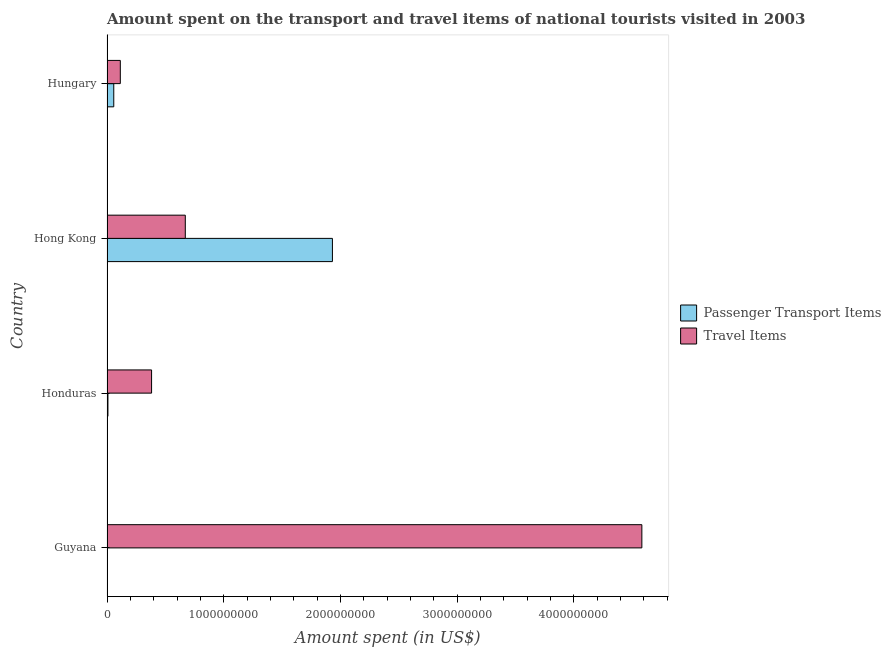How many groups of bars are there?
Ensure brevity in your answer.  4. Are the number of bars per tick equal to the number of legend labels?
Your answer should be compact. Yes. How many bars are there on the 2nd tick from the bottom?
Make the answer very short. 2. What is the label of the 3rd group of bars from the top?
Your answer should be very brief. Honduras. In how many cases, is the number of bars for a given country not equal to the number of legend labels?
Keep it short and to the point. 0. What is the amount spent on passenger transport items in Hungary?
Provide a short and direct response. 5.80e+07. Across all countries, what is the maximum amount spent in travel items?
Your answer should be compact. 4.58e+09. Across all countries, what is the minimum amount spent in travel items?
Your response must be concise. 1.14e+08. In which country was the amount spent on passenger transport items maximum?
Your answer should be compact. Hong Kong. In which country was the amount spent in travel items minimum?
Keep it short and to the point. Hungary. What is the total amount spent on passenger transport items in the graph?
Offer a terse response. 2.00e+09. What is the difference between the amount spent on passenger transport items in Guyana and that in Honduras?
Keep it short and to the point. -6.00e+06. What is the difference between the amount spent on passenger transport items in Guyana and the amount spent in travel items in Honduras?
Keep it short and to the point. -3.80e+08. What is the average amount spent in travel items per country?
Offer a terse response. 1.44e+09. What is the difference between the amount spent in travel items and amount spent on passenger transport items in Hong Kong?
Provide a succinct answer. -1.26e+09. In how many countries, is the amount spent in travel items greater than 1000000000 US$?
Your response must be concise. 1. What is the ratio of the amount spent on passenger transport items in Guyana to that in Hong Kong?
Keep it short and to the point. 0. What is the difference between the highest and the second highest amount spent in travel items?
Offer a terse response. 3.91e+09. What is the difference between the highest and the lowest amount spent in travel items?
Provide a succinct answer. 4.47e+09. In how many countries, is the amount spent on passenger transport items greater than the average amount spent on passenger transport items taken over all countries?
Offer a terse response. 1. What does the 2nd bar from the top in Guyana represents?
Provide a succinct answer. Passenger Transport Items. What does the 1st bar from the bottom in Guyana represents?
Offer a terse response. Passenger Transport Items. How many bars are there?
Provide a succinct answer. 8. Are the values on the major ticks of X-axis written in scientific E-notation?
Offer a very short reply. No. Does the graph contain grids?
Ensure brevity in your answer.  No. Where does the legend appear in the graph?
Offer a very short reply. Center right. How are the legend labels stacked?
Make the answer very short. Vertical. What is the title of the graph?
Provide a short and direct response. Amount spent on the transport and travel items of national tourists visited in 2003. What is the label or title of the X-axis?
Provide a succinct answer. Amount spent (in US$). What is the label or title of the Y-axis?
Keep it short and to the point. Country. What is the Amount spent (in US$) in Travel Items in Guyana?
Provide a succinct answer. 4.58e+09. What is the Amount spent (in US$) in Passenger Transport Items in Honduras?
Provide a succinct answer. 8.00e+06. What is the Amount spent (in US$) in Travel Items in Honduras?
Ensure brevity in your answer.  3.82e+08. What is the Amount spent (in US$) in Passenger Transport Items in Hong Kong?
Offer a terse response. 1.93e+09. What is the Amount spent (in US$) in Travel Items in Hong Kong?
Make the answer very short. 6.71e+08. What is the Amount spent (in US$) in Passenger Transport Items in Hungary?
Provide a short and direct response. 5.80e+07. What is the Amount spent (in US$) in Travel Items in Hungary?
Give a very brief answer. 1.14e+08. Across all countries, what is the maximum Amount spent (in US$) of Passenger Transport Items?
Ensure brevity in your answer.  1.93e+09. Across all countries, what is the maximum Amount spent (in US$) of Travel Items?
Keep it short and to the point. 4.58e+09. Across all countries, what is the minimum Amount spent (in US$) of Passenger Transport Items?
Offer a very short reply. 2.00e+06. Across all countries, what is the minimum Amount spent (in US$) in Travel Items?
Your response must be concise. 1.14e+08. What is the total Amount spent (in US$) of Travel Items in the graph?
Provide a succinct answer. 5.75e+09. What is the difference between the Amount spent (in US$) in Passenger Transport Items in Guyana and that in Honduras?
Provide a short and direct response. -6.00e+06. What is the difference between the Amount spent (in US$) of Travel Items in Guyana and that in Honduras?
Offer a terse response. 4.20e+09. What is the difference between the Amount spent (in US$) in Passenger Transport Items in Guyana and that in Hong Kong?
Keep it short and to the point. -1.93e+09. What is the difference between the Amount spent (in US$) of Travel Items in Guyana and that in Hong Kong?
Ensure brevity in your answer.  3.91e+09. What is the difference between the Amount spent (in US$) of Passenger Transport Items in Guyana and that in Hungary?
Offer a terse response. -5.60e+07. What is the difference between the Amount spent (in US$) in Travel Items in Guyana and that in Hungary?
Give a very brief answer. 4.47e+09. What is the difference between the Amount spent (in US$) of Passenger Transport Items in Honduras and that in Hong Kong?
Your response must be concise. -1.92e+09. What is the difference between the Amount spent (in US$) of Travel Items in Honduras and that in Hong Kong?
Provide a succinct answer. -2.89e+08. What is the difference between the Amount spent (in US$) in Passenger Transport Items in Honduras and that in Hungary?
Offer a terse response. -5.00e+07. What is the difference between the Amount spent (in US$) of Travel Items in Honduras and that in Hungary?
Your answer should be compact. 2.68e+08. What is the difference between the Amount spent (in US$) of Passenger Transport Items in Hong Kong and that in Hungary?
Your response must be concise. 1.87e+09. What is the difference between the Amount spent (in US$) in Travel Items in Hong Kong and that in Hungary?
Your answer should be very brief. 5.57e+08. What is the difference between the Amount spent (in US$) of Passenger Transport Items in Guyana and the Amount spent (in US$) of Travel Items in Honduras?
Your answer should be very brief. -3.80e+08. What is the difference between the Amount spent (in US$) in Passenger Transport Items in Guyana and the Amount spent (in US$) in Travel Items in Hong Kong?
Offer a very short reply. -6.69e+08. What is the difference between the Amount spent (in US$) of Passenger Transport Items in Guyana and the Amount spent (in US$) of Travel Items in Hungary?
Your answer should be compact. -1.12e+08. What is the difference between the Amount spent (in US$) in Passenger Transport Items in Honduras and the Amount spent (in US$) in Travel Items in Hong Kong?
Provide a succinct answer. -6.63e+08. What is the difference between the Amount spent (in US$) in Passenger Transport Items in Honduras and the Amount spent (in US$) in Travel Items in Hungary?
Keep it short and to the point. -1.06e+08. What is the difference between the Amount spent (in US$) of Passenger Transport Items in Hong Kong and the Amount spent (in US$) of Travel Items in Hungary?
Give a very brief answer. 1.82e+09. What is the average Amount spent (in US$) in Travel Items per country?
Your answer should be very brief. 1.44e+09. What is the difference between the Amount spent (in US$) of Passenger Transport Items and Amount spent (in US$) of Travel Items in Guyana?
Ensure brevity in your answer.  -4.58e+09. What is the difference between the Amount spent (in US$) in Passenger Transport Items and Amount spent (in US$) in Travel Items in Honduras?
Give a very brief answer. -3.74e+08. What is the difference between the Amount spent (in US$) in Passenger Transport Items and Amount spent (in US$) in Travel Items in Hong Kong?
Your response must be concise. 1.26e+09. What is the difference between the Amount spent (in US$) in Passenger Transport Items and Amount spent (in US$) in Travel Items in Hungary?
Your answer should be compact. -5.60e+07. What is the ratio of the Amount spent (in US$) in Travel Items in Guyana to that in Hong Kong?
Keep it short and to the point. 6.83. What is the ratio of the Amount spent (in US$) in Passenger Transport Items in Guyana to that in Hungary?
Give a very brief answer. 0.03. What is the ratio of the Amount spent (in US$) of Travel Items in Guyana to that in Hungary?
Give a very brief answer. 40.21. What is the ratio of the Amount spent (in US$) of Passenger Transport Items in Honduras to that in Hong Kong?
Your response must be concise. 0. What is the ratio of the Amount spent (in US$) in Travel Items in Honduras to that in Hong Kong?
Your response must be concise. 0.57. What is the ratio of the Amount spent (in US$) of Passenger Transport Items in Honduras to that in Hungary?
Make the answer very short. 0.14. What is the ratio of the Amount spent (in US$) in Travel Items in Honduras to that in Hungary?
Your response must be concise. 3.35. What is the ratio of the Amount spent (in US$) of Passenger Transport Items in Hong Kong to that in Hungary?
Provide a short and direct response. 33.31. What is the ratio of the Amount spent (in US$) in Travel Items in Hong Kong to that in Hungary?
Give a very brief answer. 5.89. What is the difference between the highest and the second highest Amount spent (in US$) in Passenger Transport Items?
Your answer should be compact. 1.87e+09. What is the difference between the highest and the second highest Amount spent (in US$) of Travel Items?
Offer a terse response. 3.91e+09. What is the difference between the highest and the lowest Amount spent (in US$) in Passenger Transport Items?
Your response must be concise. 1.93e+09. What is the difference between the highest and the lowest Amount spent (in US$) in Travel Items?
Your answer should be compact. 4.47e+09. 